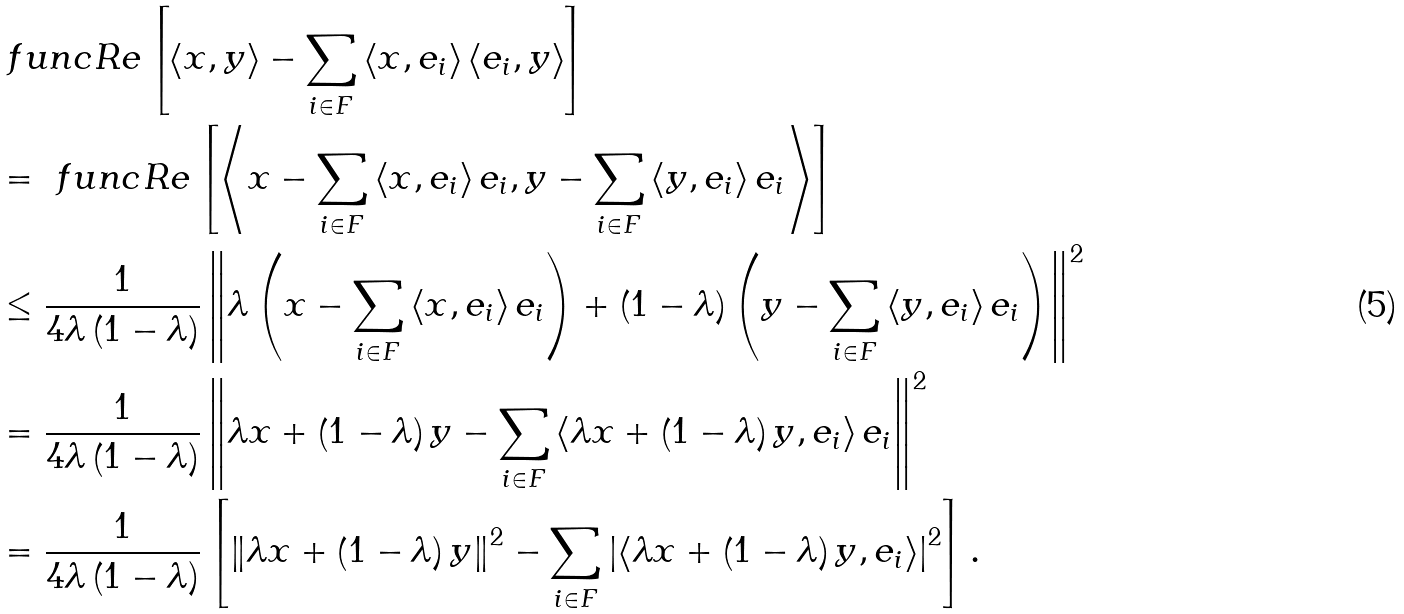Convert formula to latex. <formula><loc_0><loc_0><loc_500><loc_500>& \ f u n c { R e } \left [ \left \langle x , y \right \rangle - \sum _ { i \in F } \left \langle x , e _ { i } \right \rangle \left \langle e _ { i } , y \right \rangle \right ] \\ & = \ f u n c { R e } \left [ \left \langle x - \sum _ { i \in F } \left \langle x , e _ { i } \right \rangle e _ { i } , y - \sum _ { i \in F } \left \langle y , e _ { i } \right \rangle e _ { i } \right \rangle \right ] \\ & \leq \frac { 1 } { 4 \lambda \left ( 1 - \lambda \right ) } \left \| \lambda \left ( x - \sum _ { i \in F } \left \langle x , e _ { i } \right \rangle e _ { i } \right ) + \left ( 1 - \lambda \right ) \left ( y - \sum _ { i \in F } \left \langle y , e _ { i } \right \rangle e _ { i } \right ) \right \| ^ { 2 } \\ & = \frac { 1 } { 4 \lambda \left ( 1 - \lambda \right ) } \left \| \lambda x + \left ( 1 - \lambda \right ) y - \sum _ { i \in F } \left \langle \lambda x + \left ( 1 - \lambda \right ) y , e _ { i } \right \rangle e _ { i } \right \| ^ { 2 } \\ & = \frac { 1 } { 4 \lambda \left ( 1 - \lambda \right ) } \left [ \left \| \lambda x + \left ( 1 - \lambda \right ) y \right \| ^ { 2 } - \sum _ { i \in F } \left | \left \langle \lambda x + \left ( 1 - \lambda \right ) y , e _ { i } \right \rangle \right | ^ { 2 } \right ] .</formula> 